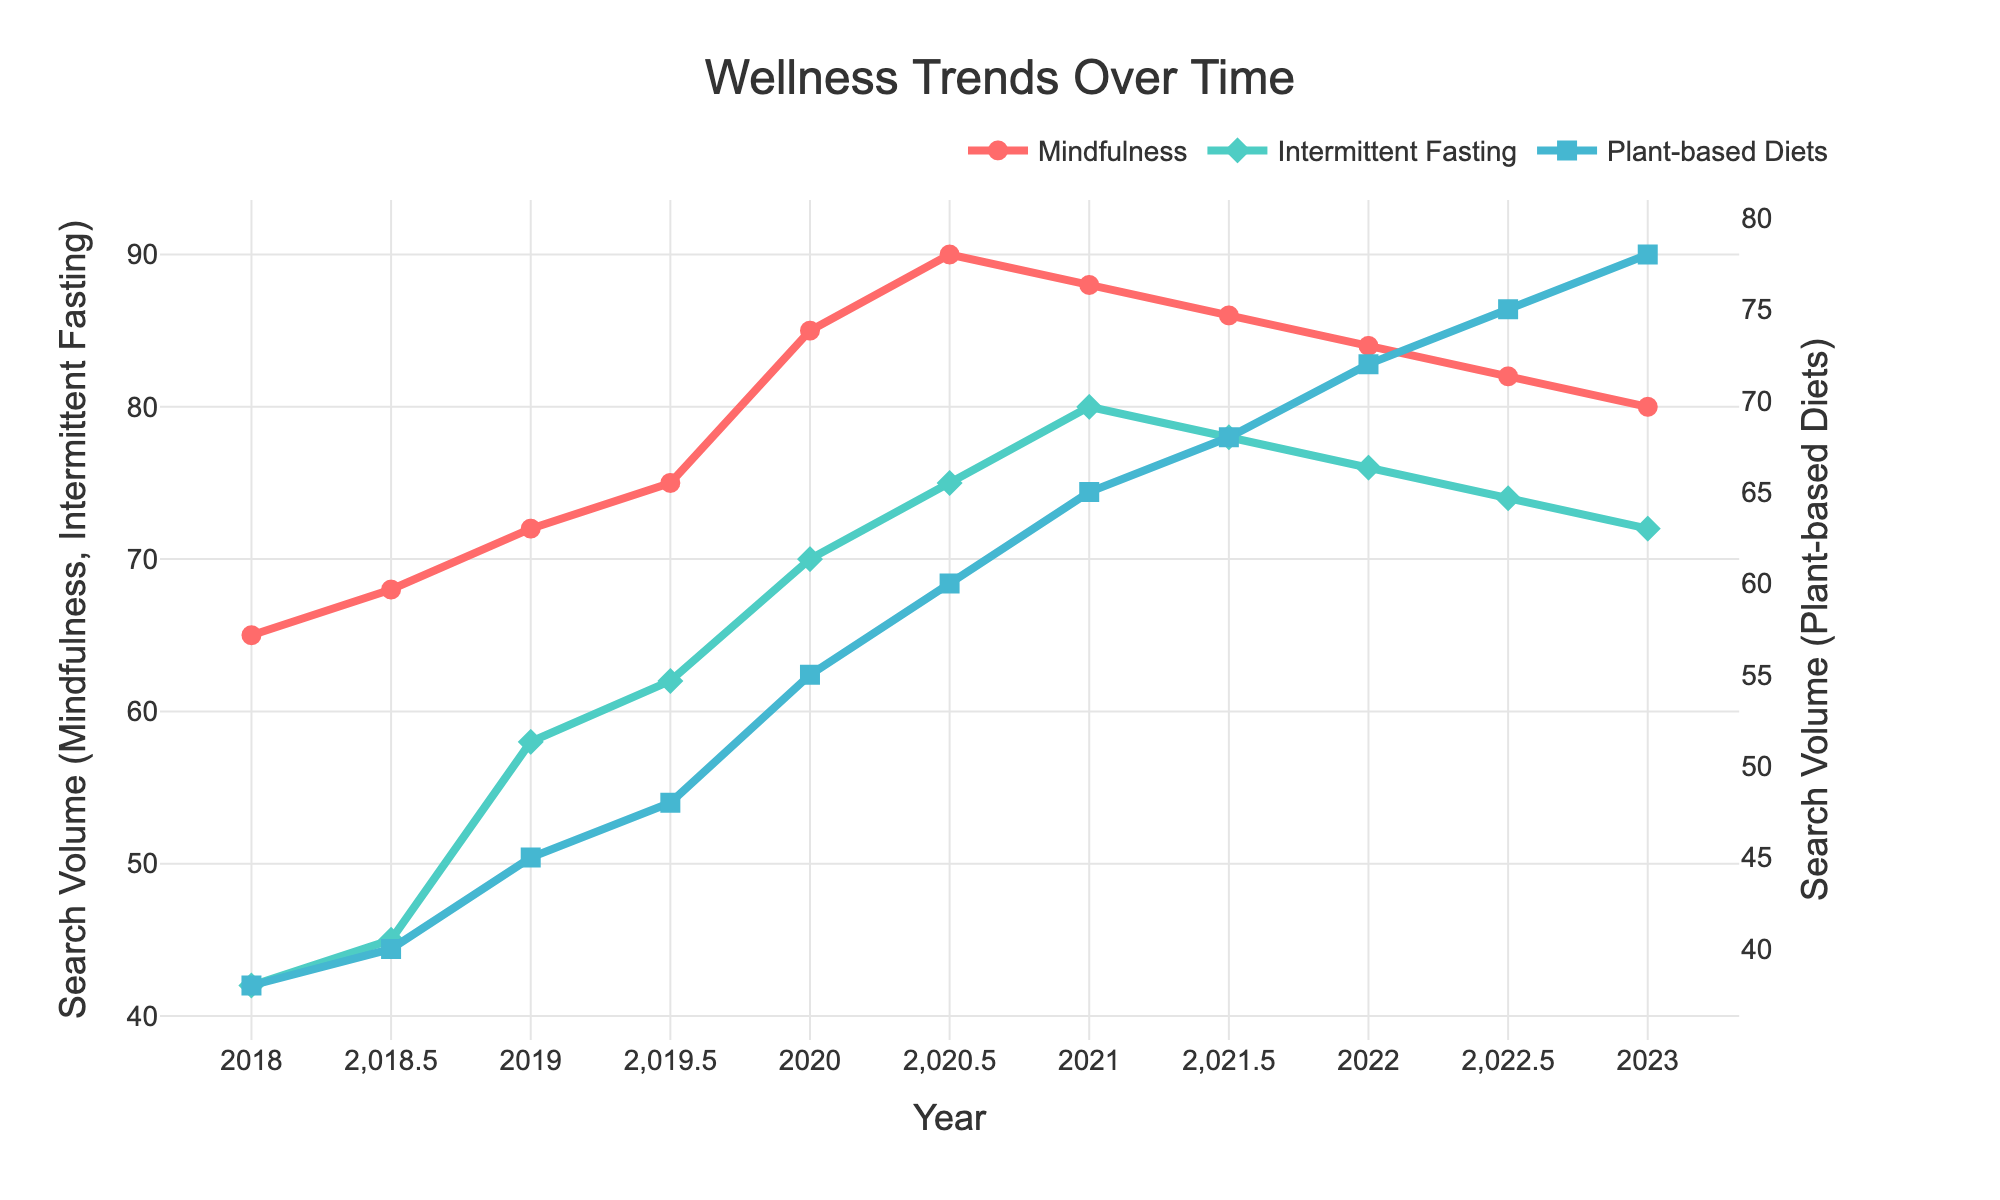What's the search volume for Intermittent Fasting in 2023? The line chart indicates search volumes for each wellness trend. For Intermittent Fasting in 2023, locate the 2023 point on the x-axis and refer to the corresponding value on the y-axis for the green line.
Answer: 72 When did Mindfulness search volume peak? Observing the red line for the significant upwards trend and subsequent peak, it appears the highest point is around 2020.5.
Answer: 2020.5 Which trend had the greatest increase in search volume between 2019 and 2020? By comparing the differences in y-values between 2019 and 2020 for all three lines, we see that the red line (Mindfulness) has the most significant spike from 75 (2019) to 85 (2020).
Answer: Mindfulness What's the difference in search volume between Plant-based Diets and Mindfulness in 2023? In 2023, the Mindfulness search volume is 80, and the Plant-based Diets search volume is 78. The difference is calculated as 80 - 78.
Answer: 2 Compare the search volumes for Intermittent Fasting and Mindfulness in 2021. Which one was higher? Checking at the 2021 point on the x-axis, the red line (Mindfulness) is at 88 whereas the green line (Intermittent Fasting) is at 80. Mindfulness is higher.
Answer: Mindfulness What was the search volume for Plant-based Diets in mid-2021 (2021.5)? Locate the data point at 2021.5 for the blue line, which shows the search volume for Plant-based Diets.
Answer: 68 Which wellness trend showed the least fluctuation over the 5 years? Observing the line charts for smoothness and lesser deviations, Plant-based Diets (blue line) has the least fluctuation.
Answer: Plant-based Diets What's the average search volume for Mindfulness from 2020 to 2022? Add the Mindfulness values for each year from 2020 to 2022 (85 + 90 + 88 + 86 + 84 + 82), sum which is 515, and divide by the number of data points, which is 6. The average is 515 / 6.
Answer: 85.83 Did the search volume for any trend remain constant for any given period? Check for any horizontal segment in the lines. All trends show some variation, none remain constant.
Answer: No 